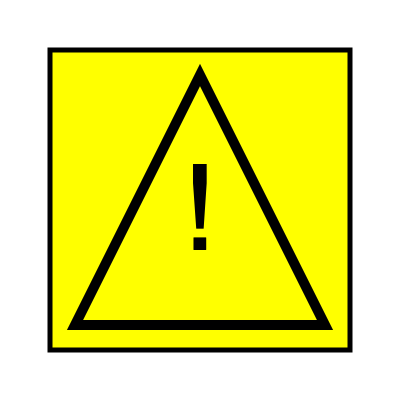What does this road sign indicate, and how should a driver respond when encountering it? To interpret this road sign correctly, let's break it down step-by-step:

1. Shape: The sign is a yellow diamond shape with a black border. This shape generally indicates a warning sign in most countries.

2. Color: Yellow is typically used for general warning signs, alerting drivers to potential hazards ahead.

3. Symbol: The sign contains a large exclamation mark ("!") in the center. This symbol is universally recognized as an indicator of caution or warning.

4. Meaning: This sign is known as a "General Warning" or "Other Dangers" sign. It alerts drivers to be cautious of potential hazards that are not covered by more specific warning signs.

5. Driver response:
   a) Reduce speed: The driver should slow down to a safe speed.
   b) Increase alertness: Be prepared for unexpected hazards on the road ahead.
   c) Scan the environment: Look for any potential dangers or unusual conditions.
   d) Be ready to take action: Prepare to brake, change lanes, or maneuver if necessary.

6. Possible hazards: This sign might be used for various situations such as:
   - Unusual road conditions
   - Temporary hazards (e.g., road work, accidents)
   - Areas prone to natural hazards (e.g., falling rocks, strong winds)

By recognizing and responding appropriately to this sign, drivers can enhance their safety and the safety of others on the road.
Answer: General Warning sign; slow down and increase alertness for potential hazards. 